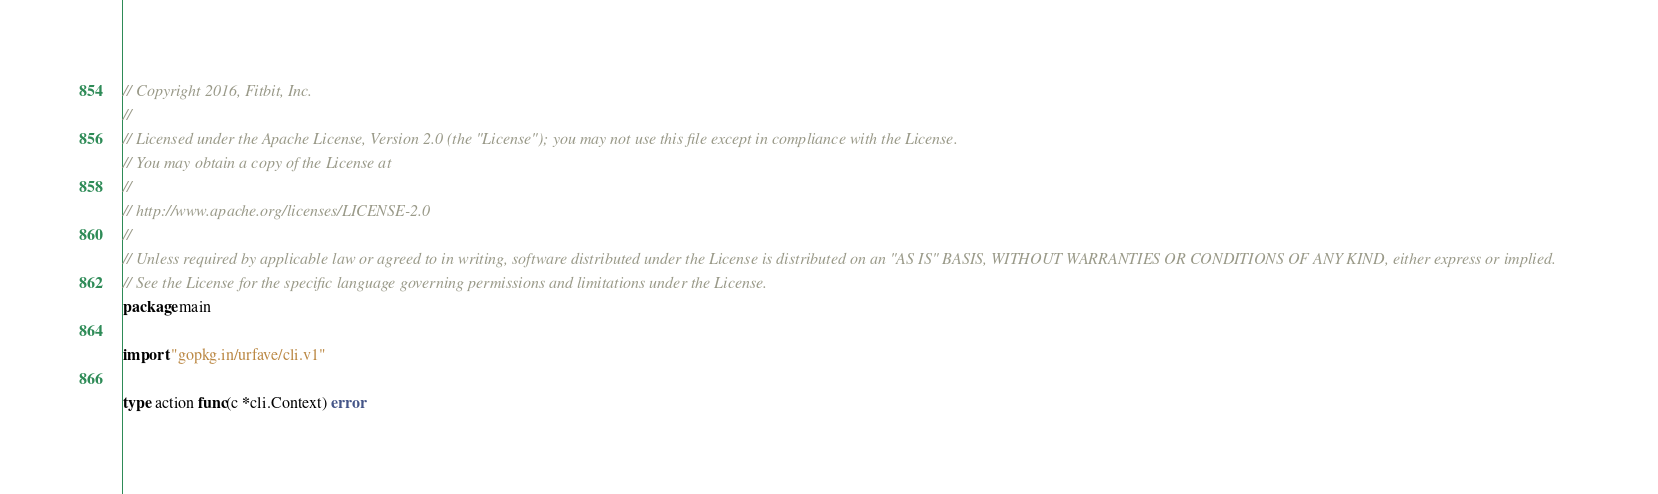Convert code to text. <code><loc_0><loc_0><loc_500><loc_500><_Go_>// Copyright 2016, Fitbit, Inc.
//
// Licensed under the Apache License, Version 2.0 (the "License"); you may not use this file except in compliance with the License.
// You may obtain a copy of the License at
//
// http://www.apache.org/licenses/LICENSE-2.0
//
// Unless required by applicable law or agreed to in writing, software distributed under the License is distributed on an "AS IS" BASIS, WITHOUT WARRANTIES OR CONDITIONS OF ANY KIND, either express or implied.
// See the License for the specific language governing permissions and limitations under the License.
package main

import "gopkg.in/urfave/cli.v1"

type action func(c *cli.Context) error
</code> 